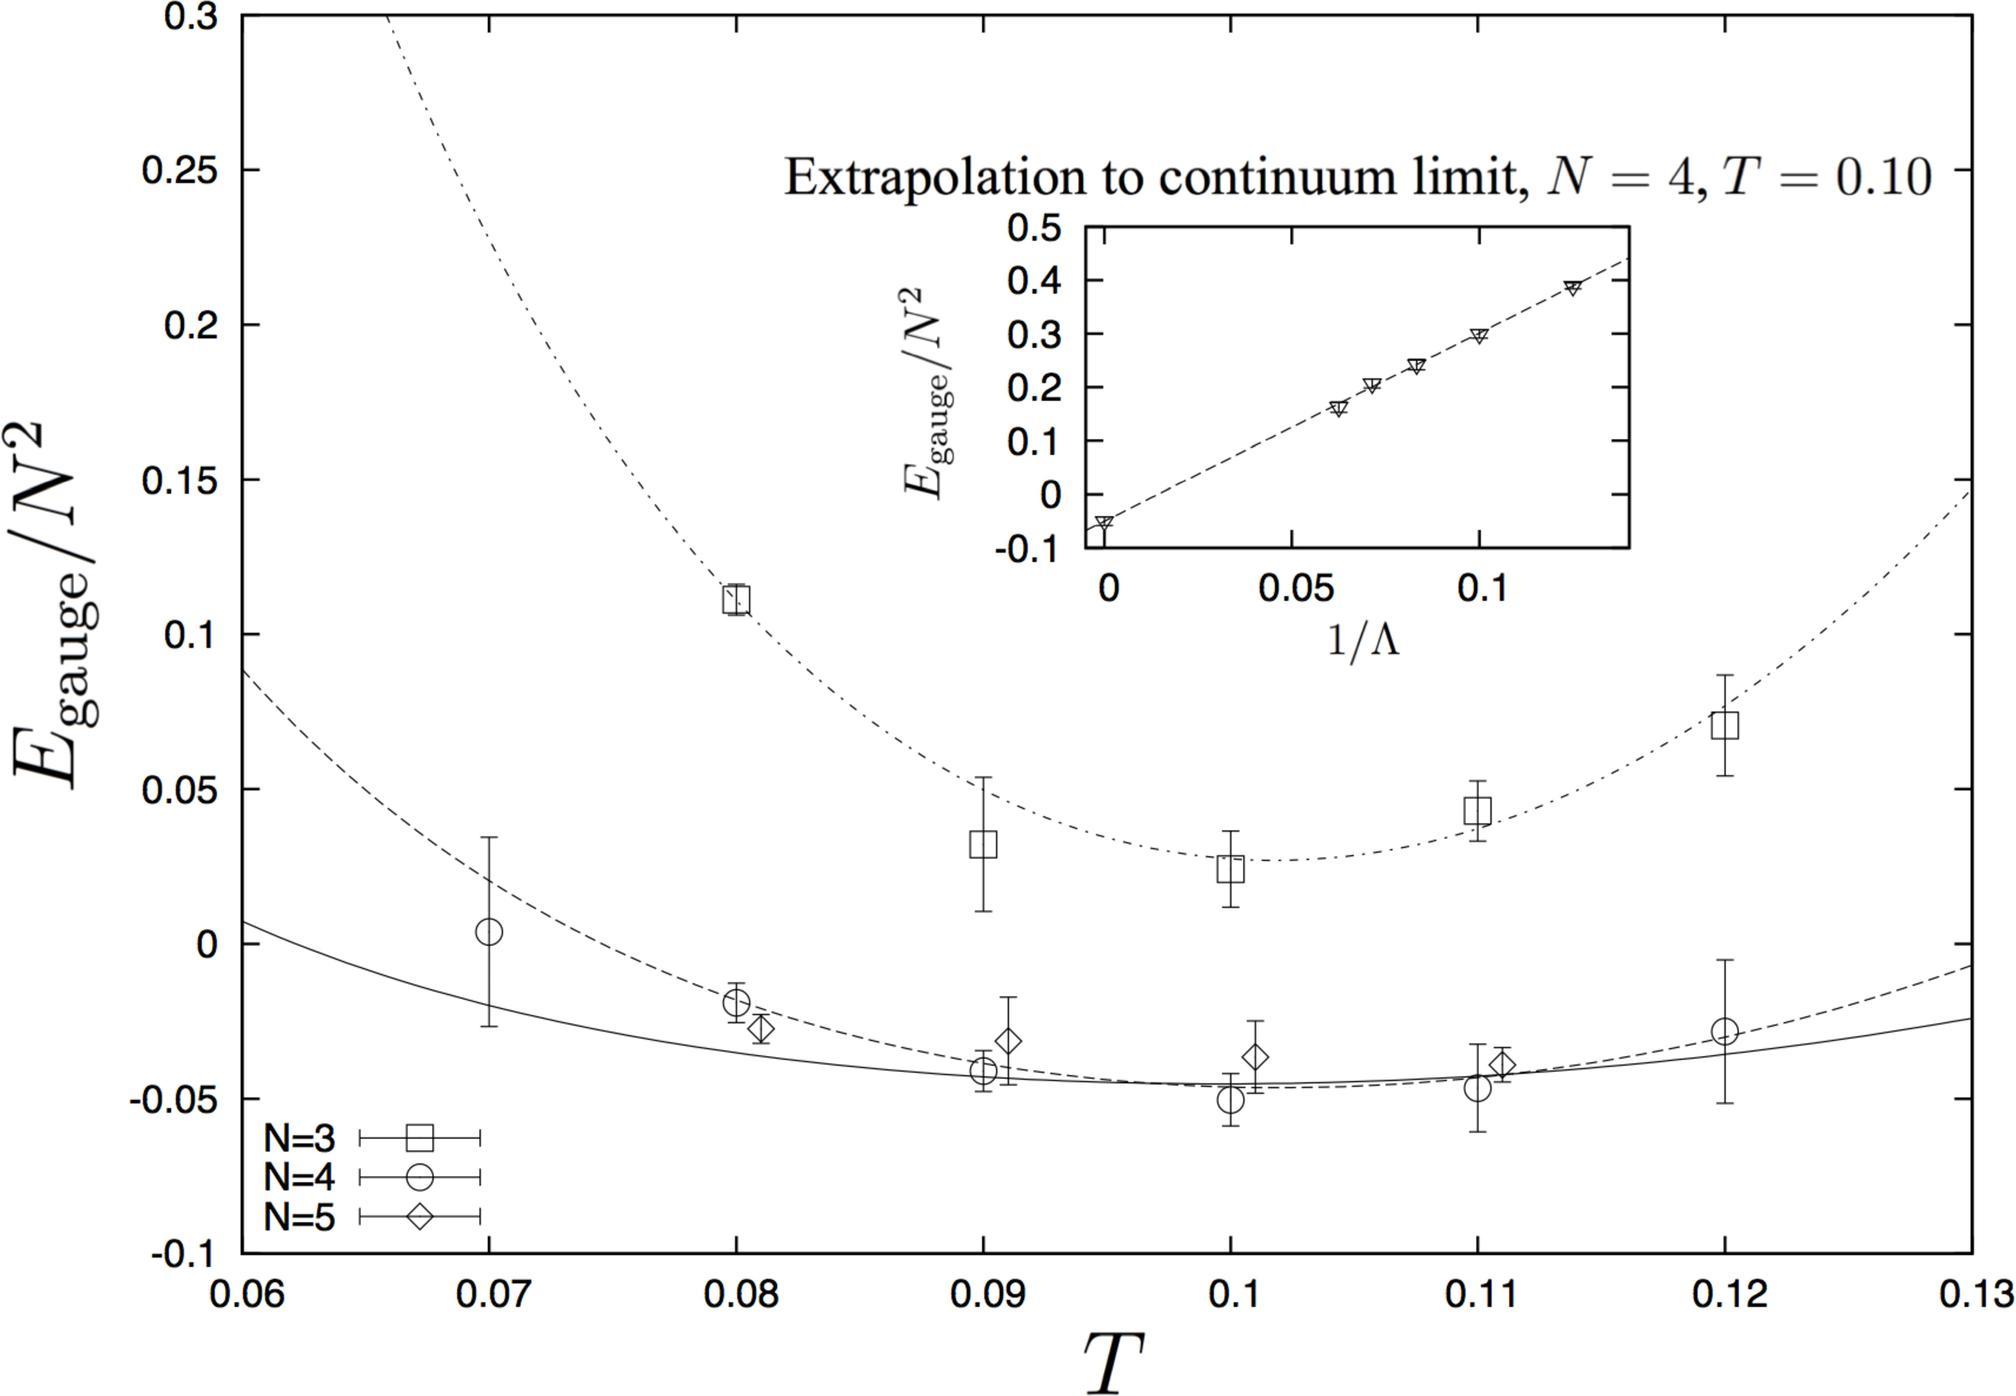What does the inset graph in the figure represent? A magnified section of the main graph. An unrelated dataset for comparison. Extrapolation to the continuum limit for N = 4 at T = 0.10. A theoretical prediction of the gauge energy at different temperatures. - The inset graph is labeled "Extrapolation to continuum limit, N = 4, T = 0.10," indicating that it is showing the extrapolation of the gauge energy to the continuum limit for a specific N value and temperature. Therefore, the correct answer is C. 